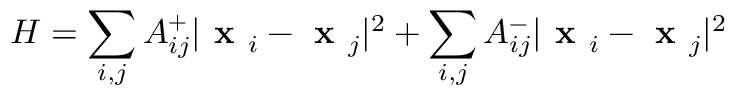<formula> <loc_0><loc_0><loc_500><loc_500>H = \sum _ { i , j } A _ { i j } ^ { + } | x _ { i } - x _ { j } | ^ { 2 } + \sum _ { i , j } A _ { i j } ^ { - } | x _ { i } - x _ { j } | ^ { 2 }</formula> 